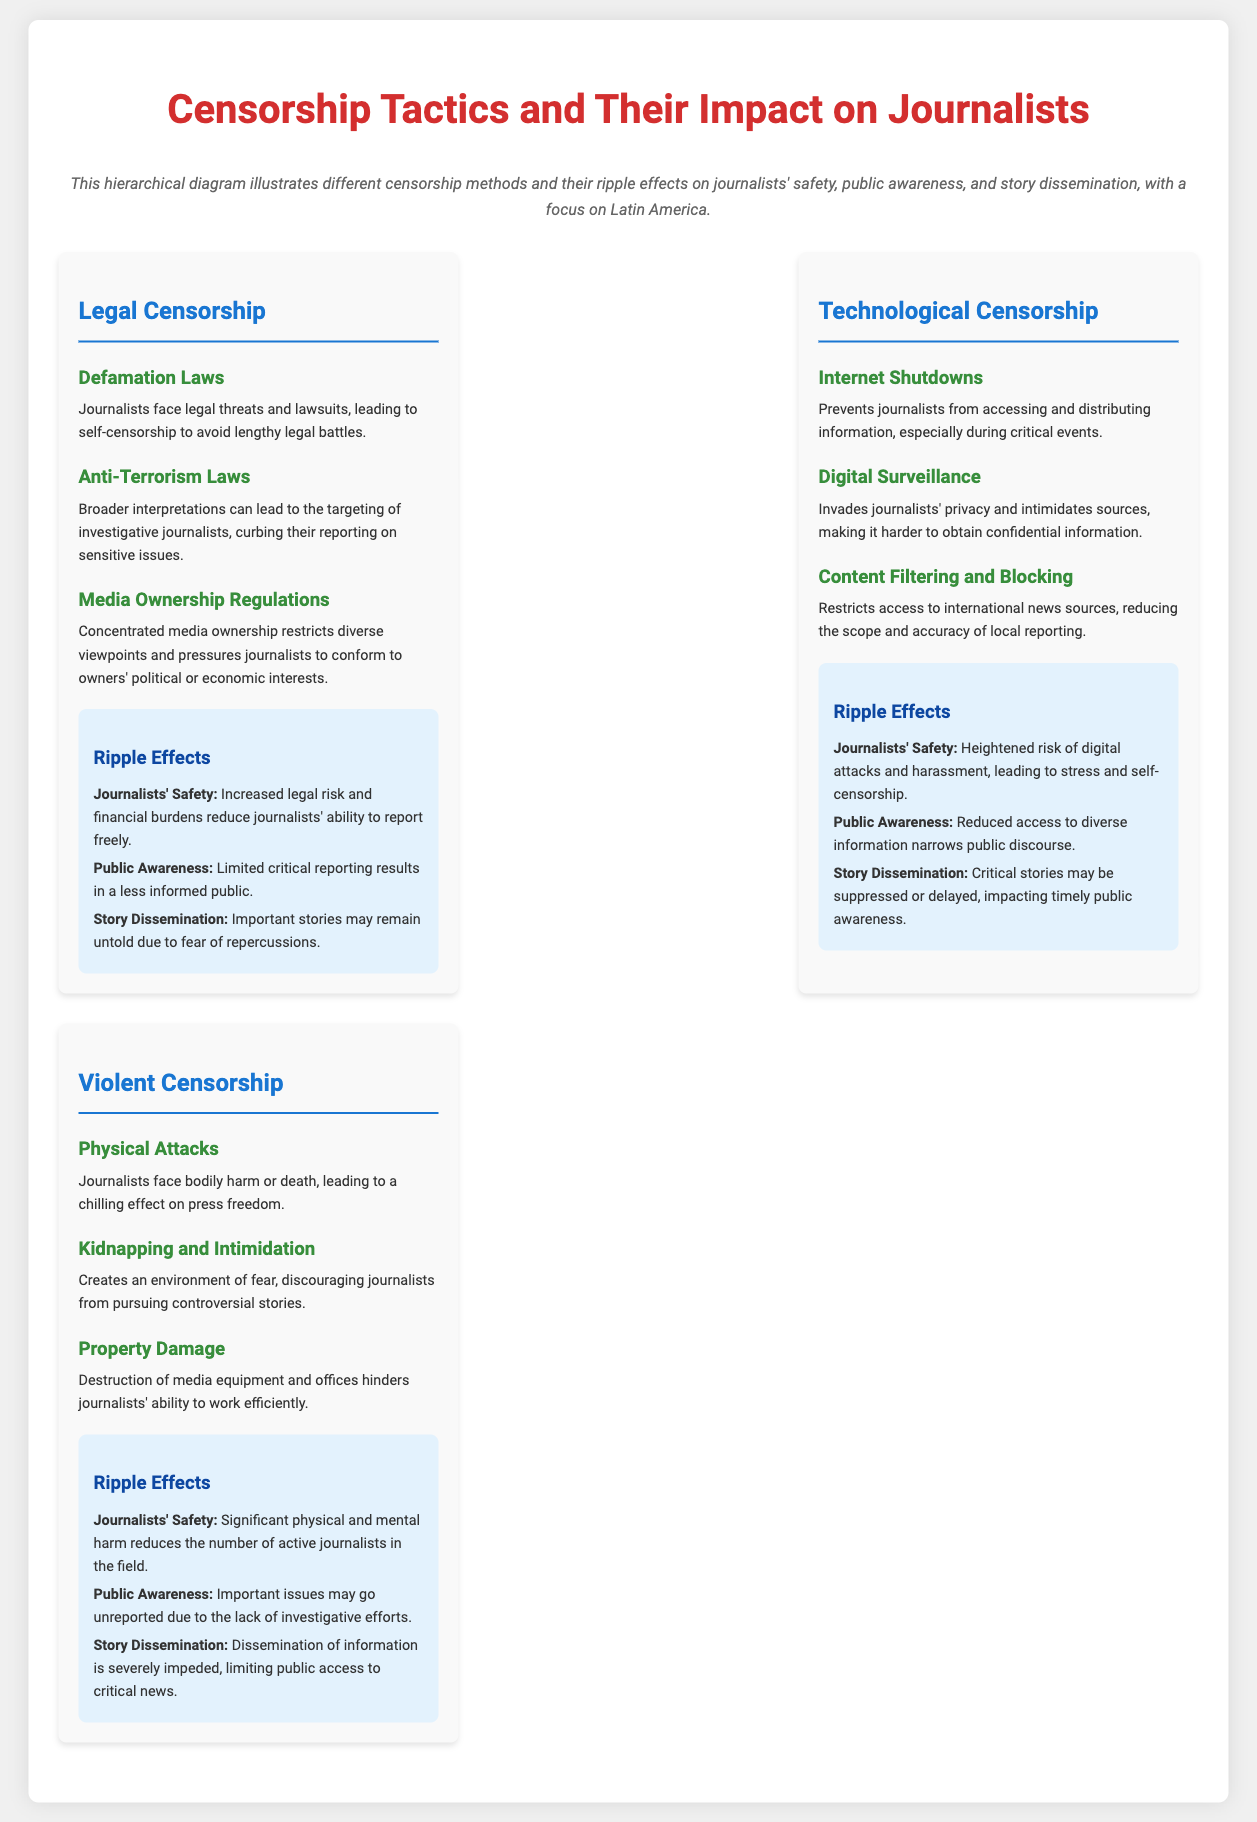What are the three main types of censorship discussed? The document outlines three categories of censorship: Legal, Technological, and Violent.
Answer: Legal, Technological, Violent Which legal method involves lawsuits against journalists? The document mentions defamation laws as a legal method resulting in lawsuits against journalists.
Answer: Defamation Laws What impact does digital surveillance have on journalists? The document states that digital surveillance invades privacy and intimidates sources, thereby complicating information gathering.
Answer: Intimidation of sources How does internet shutdown affect journalists during events? The document explains that internet shutdowns prevent journalists from accessing and distributing information, particularly during critical events.
Answer: Prevents access and distribution What is one ripple effect of violent censorship on the public? The document states that important issues may go unreported due to violent censorship, affecting public knowledge.
Answer: Unreported important issues How many ripple effects are associated with each censorship method? The document highlights three ripple effects concerning journalists' safety, public awareness, and story dissemination for each censorship method.
Answer: Three Which technological censorship method restricts access to international news? The document identifies content filtering and blocking as a method that restricts access to international news sources.
Answer: Content Filtering and Blocking What type of attack creates fear among journalists according to violent censorship? The document categorizes kidnapping and intimidation as a violent tactic that instills fear in journalists.
Answer: Kidnapping and Intimidation What is the overall theme of the hierarchical infographic? The document discusses censorship tactics and their subsequent impact on journalists, focusing on Latin America.
Answer: Censorship and its impact on journalists 